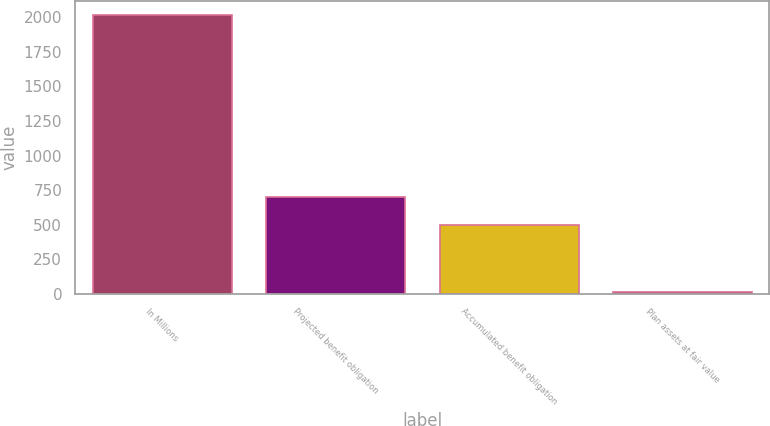Convert chart to OTSL. <chart><loc_0><loc_0><loc_500><loc_500><bar_chart><fcel>In Millions<fcel>Projected benefit obligation<fcel>Accumulated benefit obligation<fcel>Plan assets at fair value<nl><fcel>2018<fcel>699.58<fcel>498.8<fcel>10.2<nl></chart> 